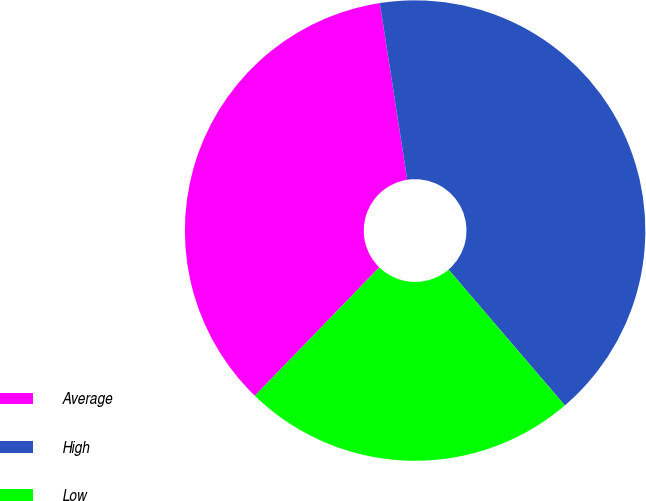Convert chart to OTSL. <chart><loc_0><loc_0><loc_500><loc_500><pie_chart><fcel>Average<fcel>High<fcel>Low<nl><fcel>35.29%<fcel>41.18%<fcel>23.53%<nl></chart> 